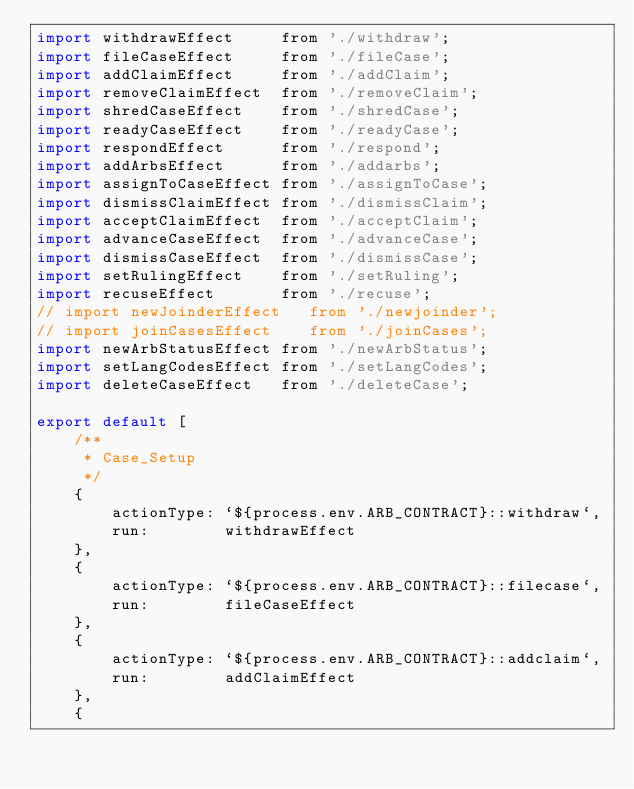<code> <loc_0><loc_0><loc_500><loc_500><_JavaScript_>import withdrawEffect     from './withdraw';
import fileCaseEffect     from './fileCase';
import addClaimEffect     from './addClaim';
import removeClaimEffect  from './removeClaim';
import shredCaseEffect    from './shredCase';
import readyCaseEffect    from './readyCase';
import respondEffect      from './respond';
import addArbsEffect      from './addarbs';
import assignToCaseEffect from './assignToCase';
import dismissClaimEffect from './dismissClaim';
import acceptClaimEffect  from './acceptClaim';
import advanceCaseEffect  from './advanceCase';
import dismissCaseEffect  from './dismissCase';
import setRulingEffect    from './setRuling';
import recuseEffect       from './recuse';
// import newJoinderEffect   from './newjoinder';
// import joinCasesEffect    from './joinCases';
import newArbStatusEffect from './newArbStatus';
import setLangCodesEffect from './setLangCodes';
import deleteCaseEffect   from './deleteCase';

export default [
    /**
     * Case_Setup 
     */
    {
        actionType: `${process.env.ARB_CONTRACT}::withdraw`,
        run:        withdrawEffect
    },
    {
        actionType: `${process.env.ARB_CONTRACT}::filecase`,
        run:        fileCaseEffect
    },
    {
        actionType: `${process.env.ARB_CONTRACT}::addclaim`,
        run:        addClaimEffect
    },
    {</code> 